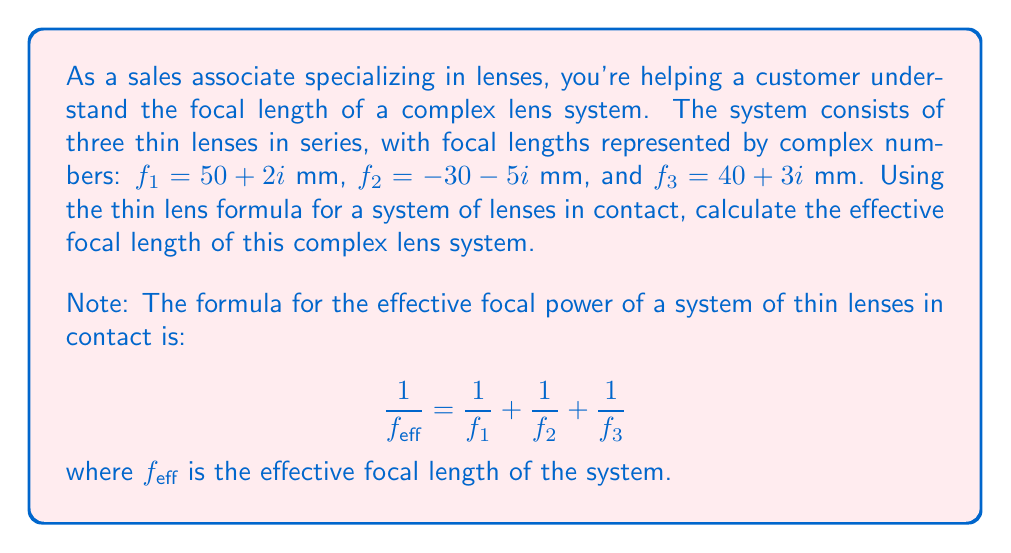Can you answer this question? Let's approach this step-by-step:

1) First, we need to calculate the reciprocal of each focal length:

   $\frac{1}{f_1} = \frac{1}{50 + 2i} = \frac{50 - 2i}{(50 + 2i)(50 - 2i)} = \frac{50 - 2i}{2504} = 0.01997 - 0.00080i$

   $\frac{1}{f_2} = \frac{1}{-30 - 5i} = \frac{-30 + 5i}{(-30 - 5i)(-30 + 5i)} = \frac{-30 + 5i}{925} = -0.03243 + 0.00541i$

   $\frac{1}{f_3} = \frac{1}{40 + 3i} = \frac{40 - 3i}{(40 + 3i)(40 - 3i)} = \frac{40 - 3i}{1609} = 0.02486 - 0.00186i$

2) Now, we sum these reciprocals:

   $\frac{1}{f_{eff}} = (0.01997 - 0.00080i) + (-0.03243 + 0.00541i) + (0.02486 - 0.00186i)$

3) Simplifying:

   $\frac{1}{f_{eff}} = 0.01240 + 0.00275i$

4) To get $f_{eff}$, we need to take the reciprocal of this complex number:

   $f_{eff} = \frac{1}{0.01240 + 0.00275i} = \frac{0.01240 - 0.00275i}{(0.01240 + 0.00275i)(0.01240 - 0.00275i)}$

   $= \frac{0.01240 - 0.00275i}{0.00015379 + 0.00000756} = \frac{0.01240 - 0.00275i}{0.00016135}$

   $= 76.85 - 17.04i$

Therefore, the effective focal length of the complex lens system is approximately 76.85 - 17.04i mm.
Answer: $f_{eff} \approx 76.85 - 17.04i$ mm 